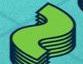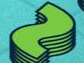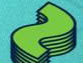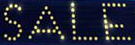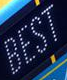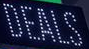What words can you see in these images in sequence, separated by a semicolon? ~; ~; ~; SALE; BEST; DEALS 